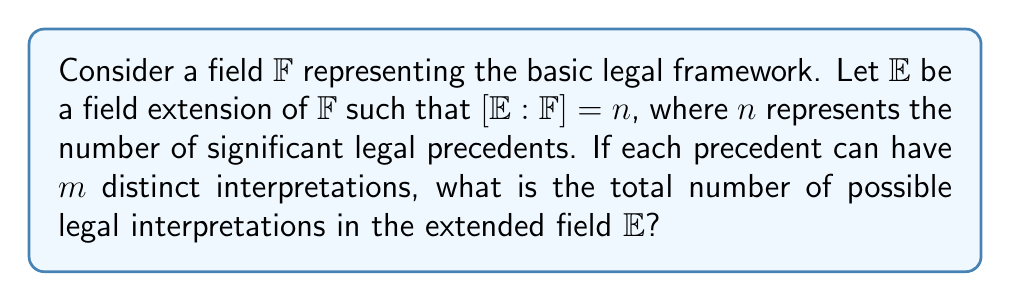Solve this math problem. 1. The field $\mathbb{F}$ represents the basic legal framework.

2. The field extension $\mathbb{E}$ of $\mathbb{F}$ represents the expanded legal framework with precedents.

3. The degree of the extension $[\mathbb{E}:\mathbb{F}] = n$ indicates there are $n$ significant legal precedents.

4. Each precedent can have $m$ distinct interpretations.

5. For each precedent, we have $m$ choices of interpretation.

6. Since there are $n$ precedents, and each can be interpreted independently, we use the multiplication principle.

7. The total number of possible legal interpretations is thus $m^n$.

8. This can be thought of as the number of elements in the Cartesian product of $n$ sets, each containing $m$ elements.

9. In field theory terms, this is analogous to the number of distinct embeddings of $\mathbb{E}$ into its algebraic closure, given that each of the $n$ generating elements has $m$ possible values.
Answer: $m^n$ 